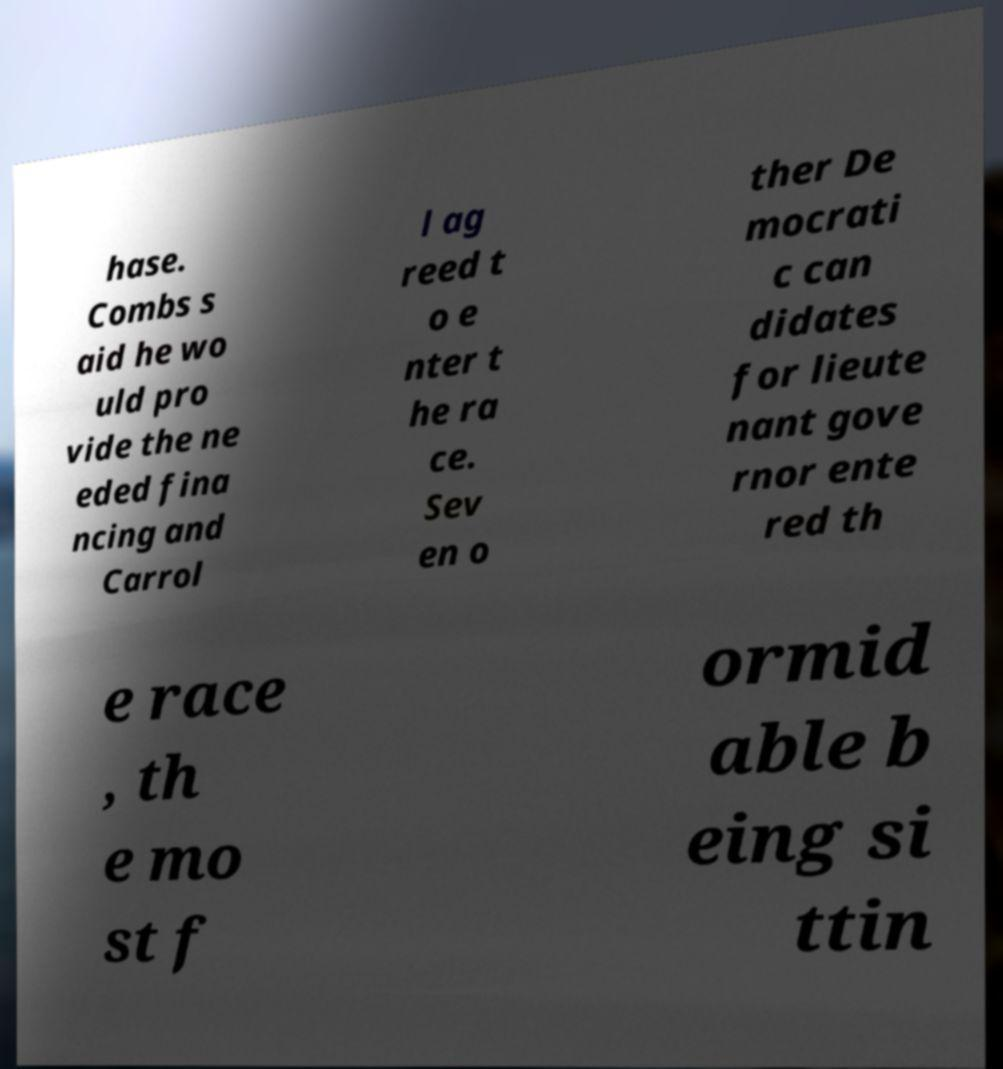Could you assist in decoding the text presented in this image and type it out clearly? hase. Combs s aid he wo uld pro vide the ne eded fina ncing and Carrol l ag reed t o e nter t he ra ce. Sev en o ther De mocrati c can didates for lieute nant gove rnor ente red th e race , th e mo st f ormid able b eing si ttin 